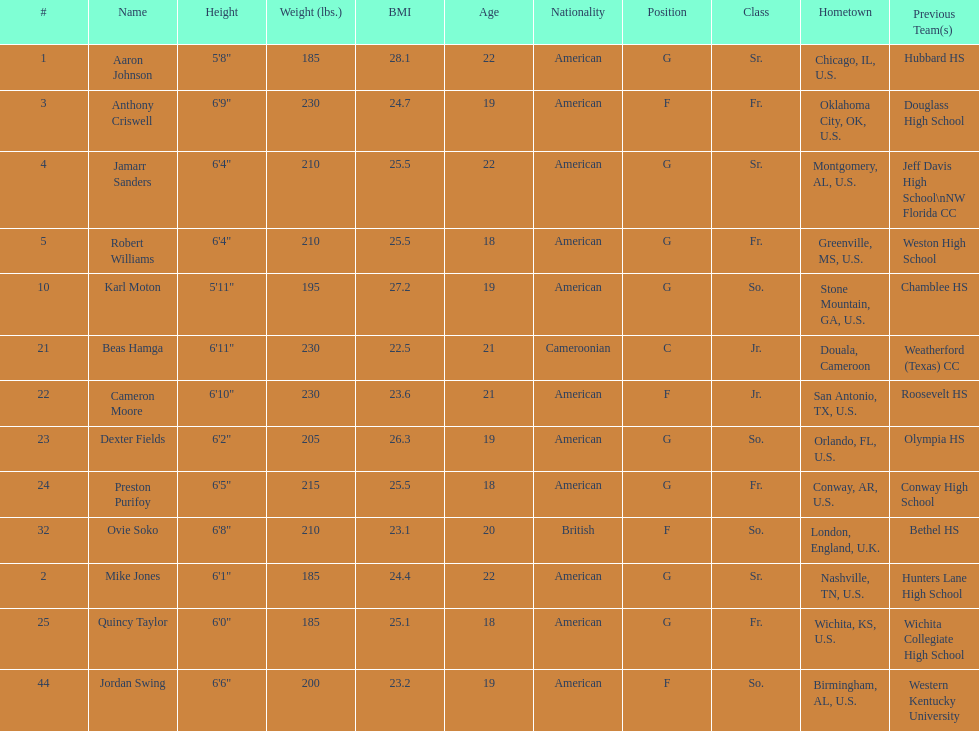Who is first on the roster? Aaron Johnson. 